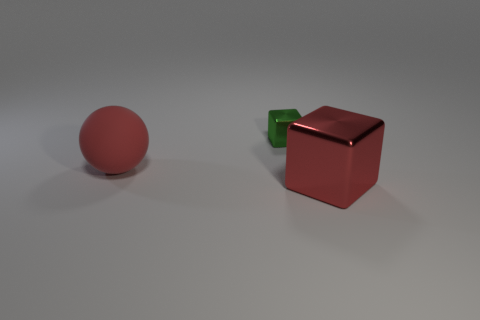Is there any other thing that has the same material as the large red ball?
Your answer should be very brief. No. Are there any other things that have the same size as the green object?
Offer a very short reply. No. Is the size of the green metallic block the same as the shiny block in front of the large red rubber ball?
Provide a succinct answer. No. Is the number of small metal objects that are behind the tiny metal thing greater than the number of large blue cylinders?
Your answer should be very brief. No. What number of rubber objects are the same size as the ball?
Your response must be concise. 0. There is a red metal thing right of the green object; is it the same size as the red object to the left of the small green metallic block?
Offer a very short reply. Yes. Is the number of red objects behind the green cube greater than the number of red blocks behind the big red sphere?
Offer a terse response. No. How many other things are the same shape as the red metallic object?
Provide a short and direct response. 1. What is the material of the object that is the same size as the red block?
Provide a succinct answer. Rubber. Are there any other large red cubes made of the same material as the big red cube?
Offer a terse response. No. 